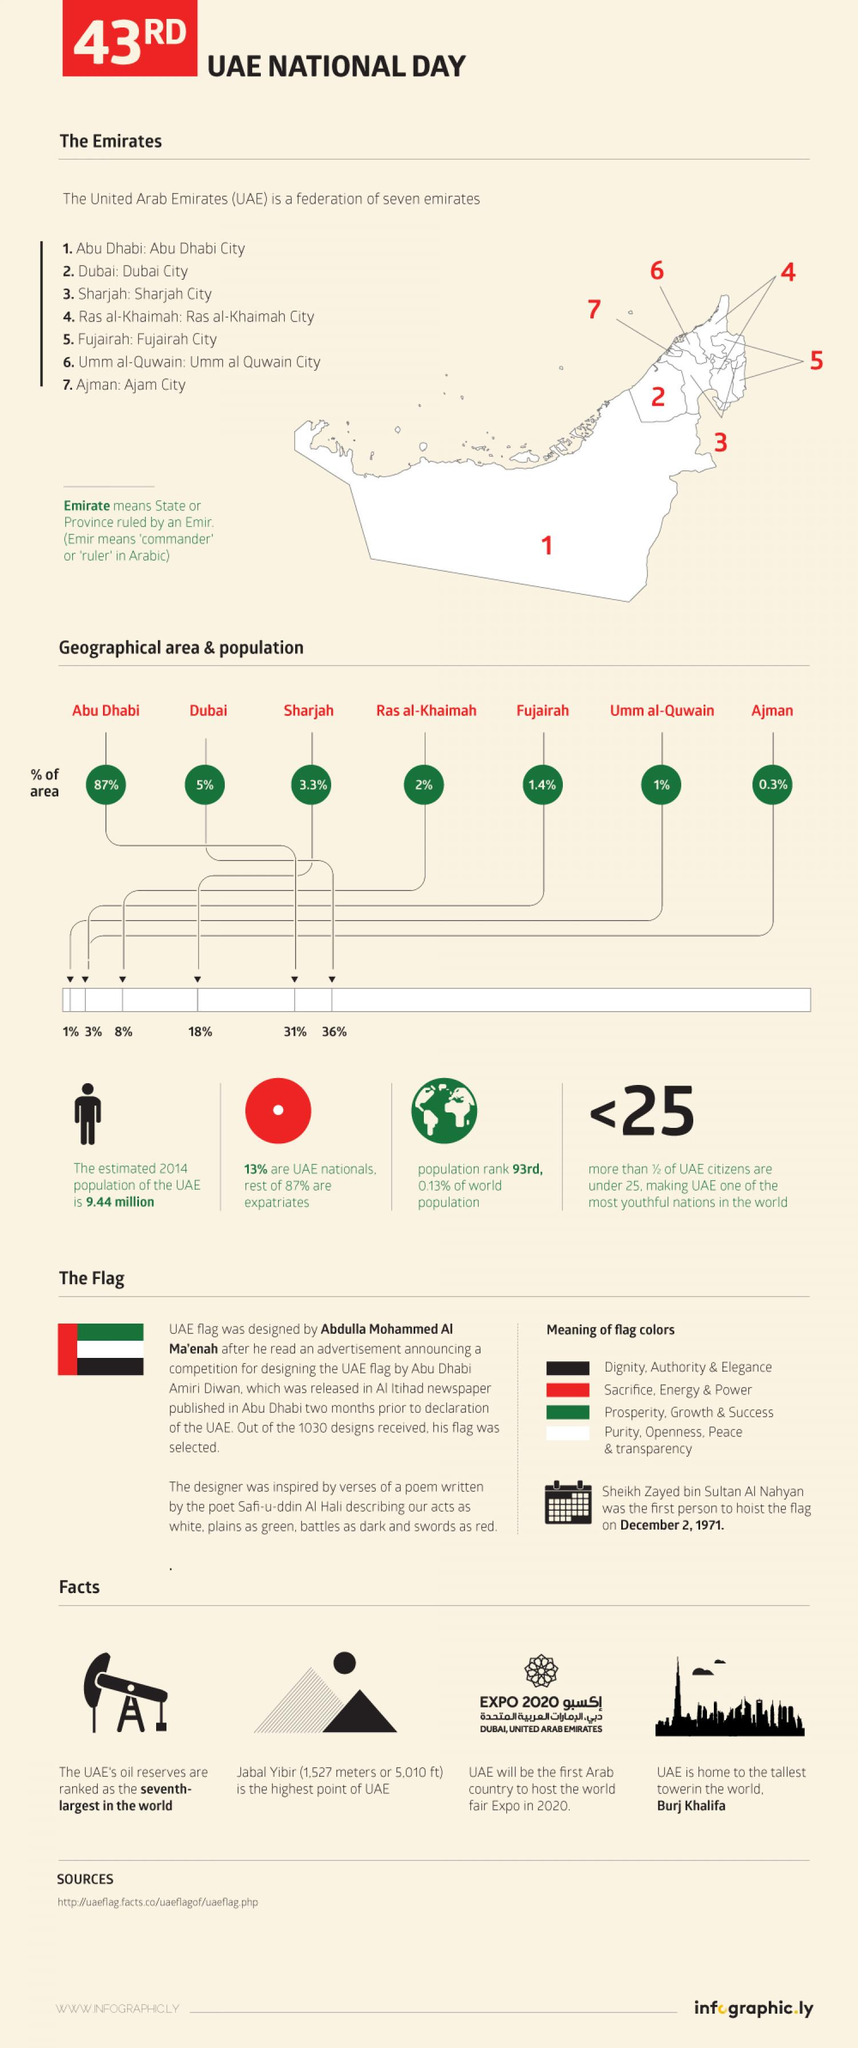Indicate a few pertinent items in this graphic. Approximately 36% of the total population of the United Arab Emirates resides in the city of Dubai. Ras al-Khaimah is the fourth largest emirate in the United Arab Emirates. Ajman City is the smallest emirate in the United Arab Emirates. Umm al Quwain City is the least populated emirate in the UAE. The Burj Khalifa is the tallest building in the world. 